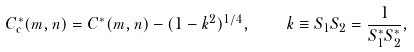Convert formula to latex. <formula><loc_0><loc_0><loc_500><loc_500>C ^ { \ast } _ { \mathrm c } ( m , n ) = C ^ { \ast } ( m , n ) - ( 1 - k ^ { 2 } ) ^ { 1 / 4 } , \quad k \equiv S _ { 1 } S _ { 2 } = \frac { 1 } { S _ { 1 } ^ { \ast } S _ { 2 } ^ { \ast } } ,</formula> 